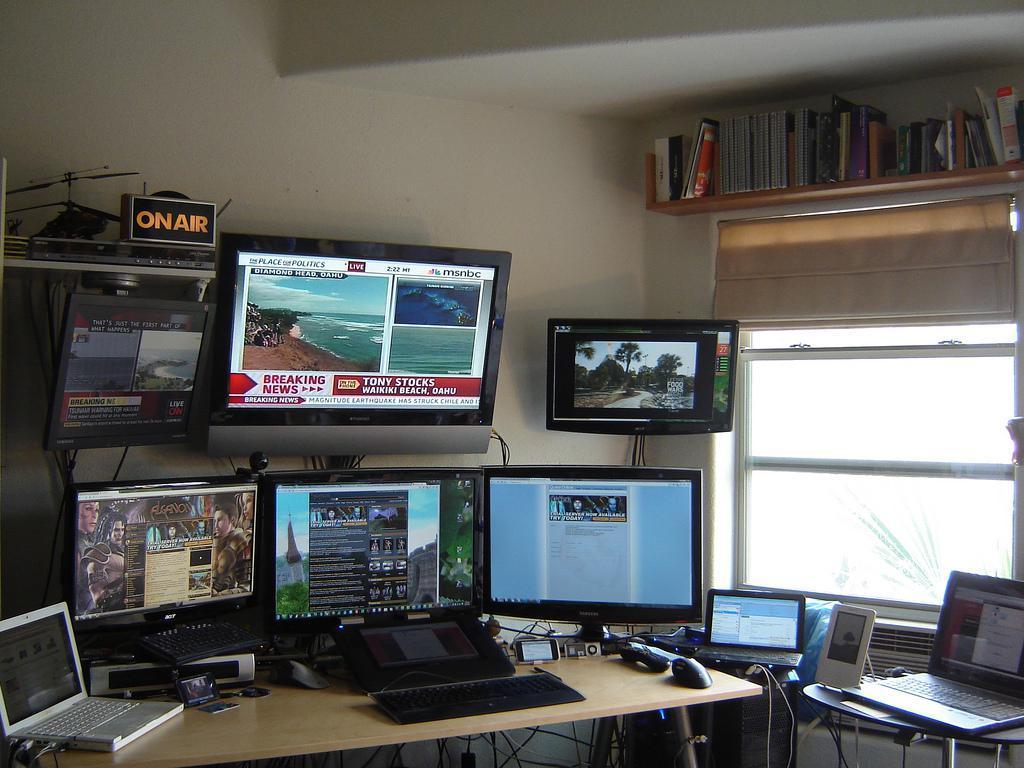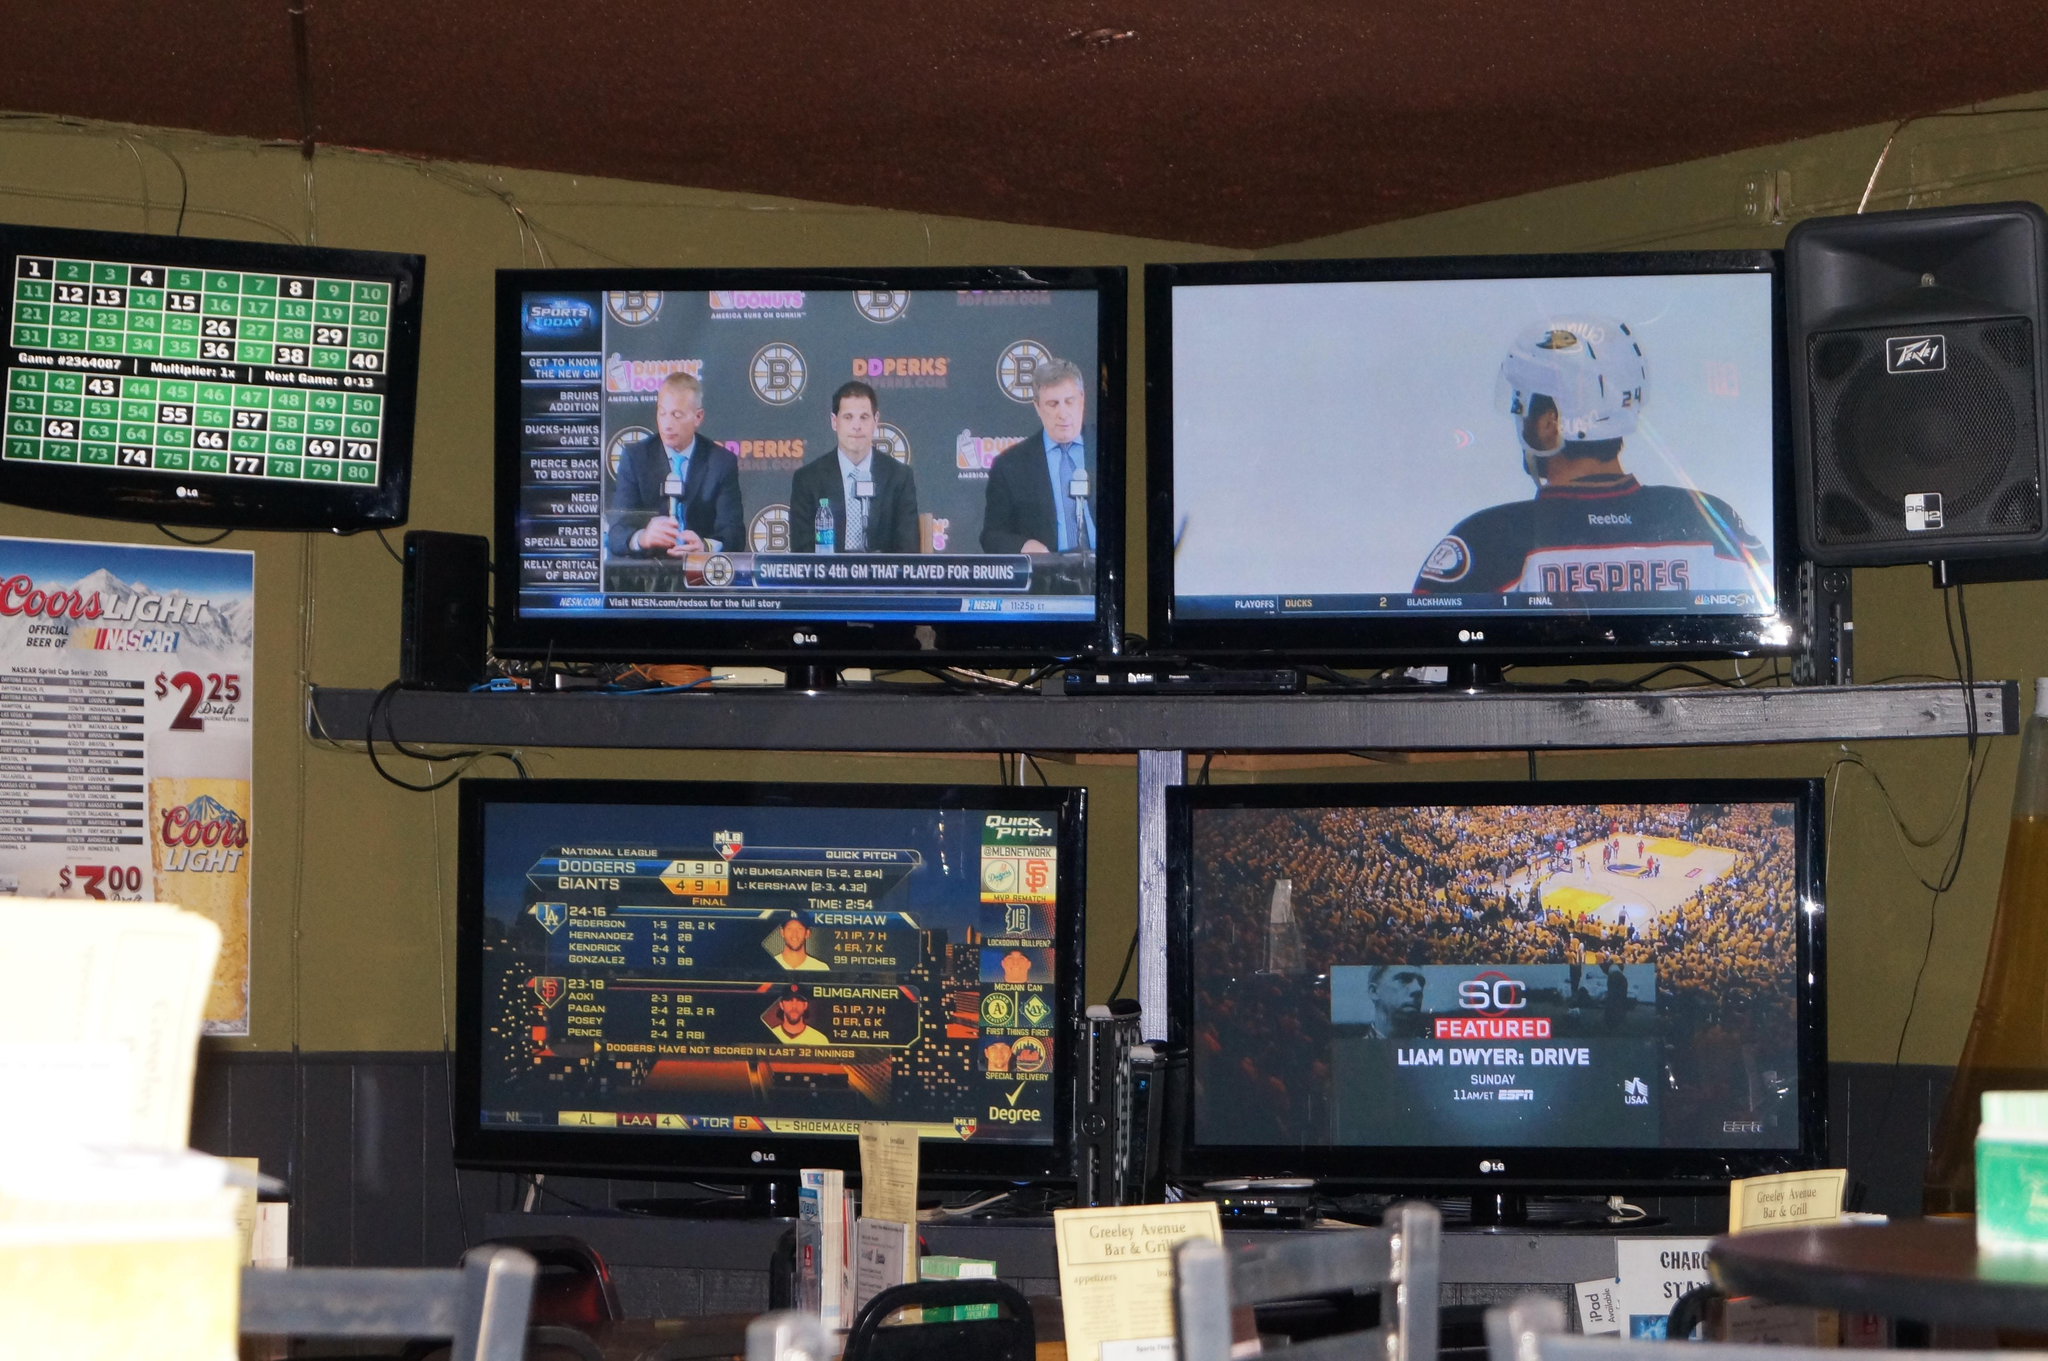The first image is the image on the left, the second image is the image on the right. Assess this claim about the two images: "Cushioned furniture is positioned near screens mounted on the wall in one of the images.". Correct or not? Answer yes or no. No. The first image is the image on the left, the second image is the image on the right. Examine the images to the left and right. Is the description "The right image shows a symmetrical grouping of at least four screens mounted on an inset wall surrounded by brown wood." accurate? Answer yes or no. No. 